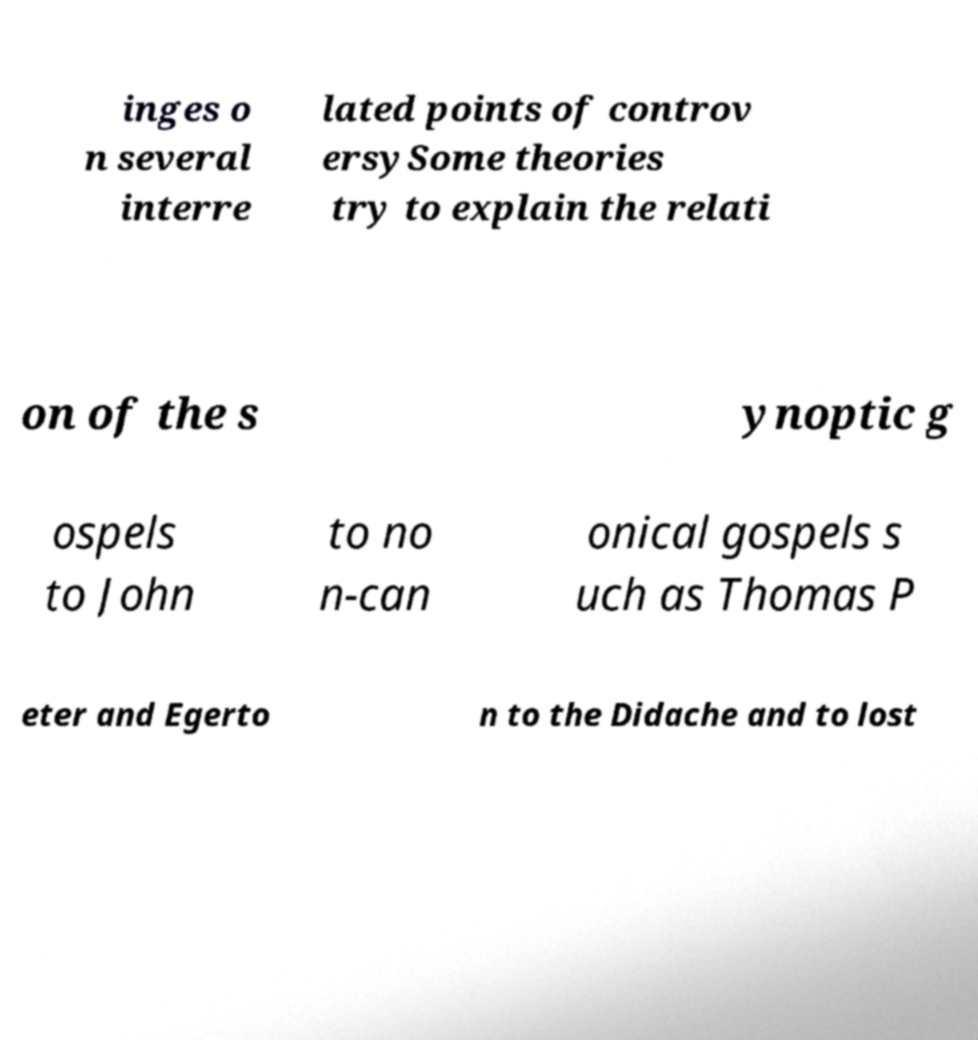Could you extract and type out the text from this image? inges o n several interre lated points of controv ersySome theories try to explain the relati on of the s ynoptic g ospels to John to no n-can onical gospels s uch as Thomas P eter and Egerto n to the Didache and to lost 